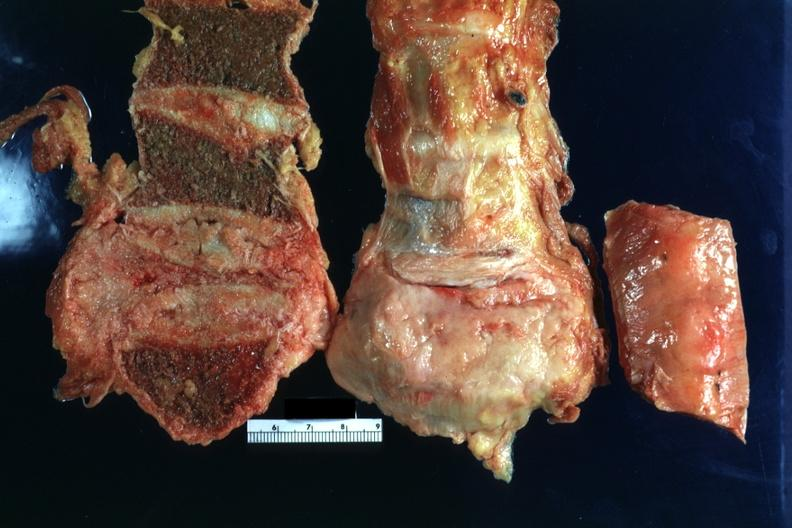s joints present?
Answer the question using a single word or phrase. Yes 